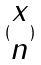<formula> <loc_0><loc_0><loc_500><loc_500>( \begin{matrix} x \\ n \end{matrix} )</formula> 